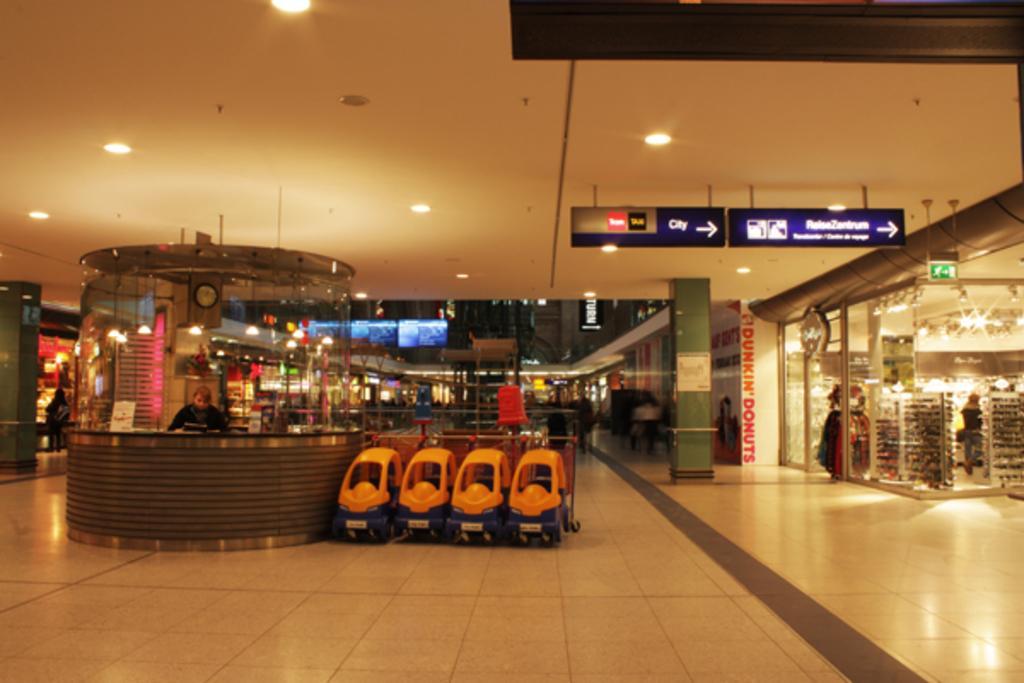Please provide a concise description of this image. In this picture we can see a few people and some objects in the stores. We can see a few objects on the floor. We can see the text, signals and a few things on the boards. There are some objects visible in the background. 